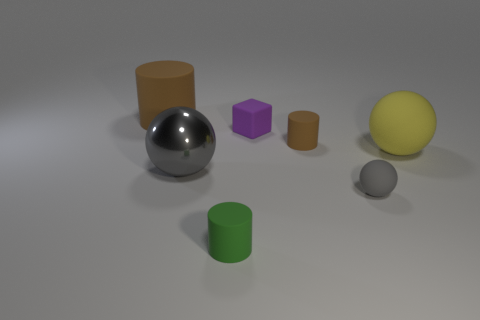Are there any other things that are the same material as the big gray object?
Offer a very short reply. No. How many other objects are there of the same shape as the small gray thing?
Provide a short and direct response. 2. There is a big thing that is behind the brown matte cylinder in front of the brown cylinder behind the tiny purple rubber block; what is its color?
Provide a succinct answer. Brown. What number of tiny gray matte spheres are there?
Your response must be concise. 1. How many small objects are either rubber things or red matte spheres?
Keep it short and to the point. 4. There is a purple object that is the same size as the green object; what shape is it?
Provide a succinct answer. Cube. There is a sphere left of the brown cylinder to the right of the small green object; what is it made of?
Offer a very short reply. Metal. Is the size of the purple rubber thing the same as the green rubber thing?
Give a very brief answer. Yes. How many objects are either things to the right of the small purple rubber thing or big brown rubber things?
Provide a succinct answer. 4. There is a large matte object that is to the left of the brown matte cylinder in front of the big matte cylinder; what shape is it?
Your response must be concise. Cylinder. 